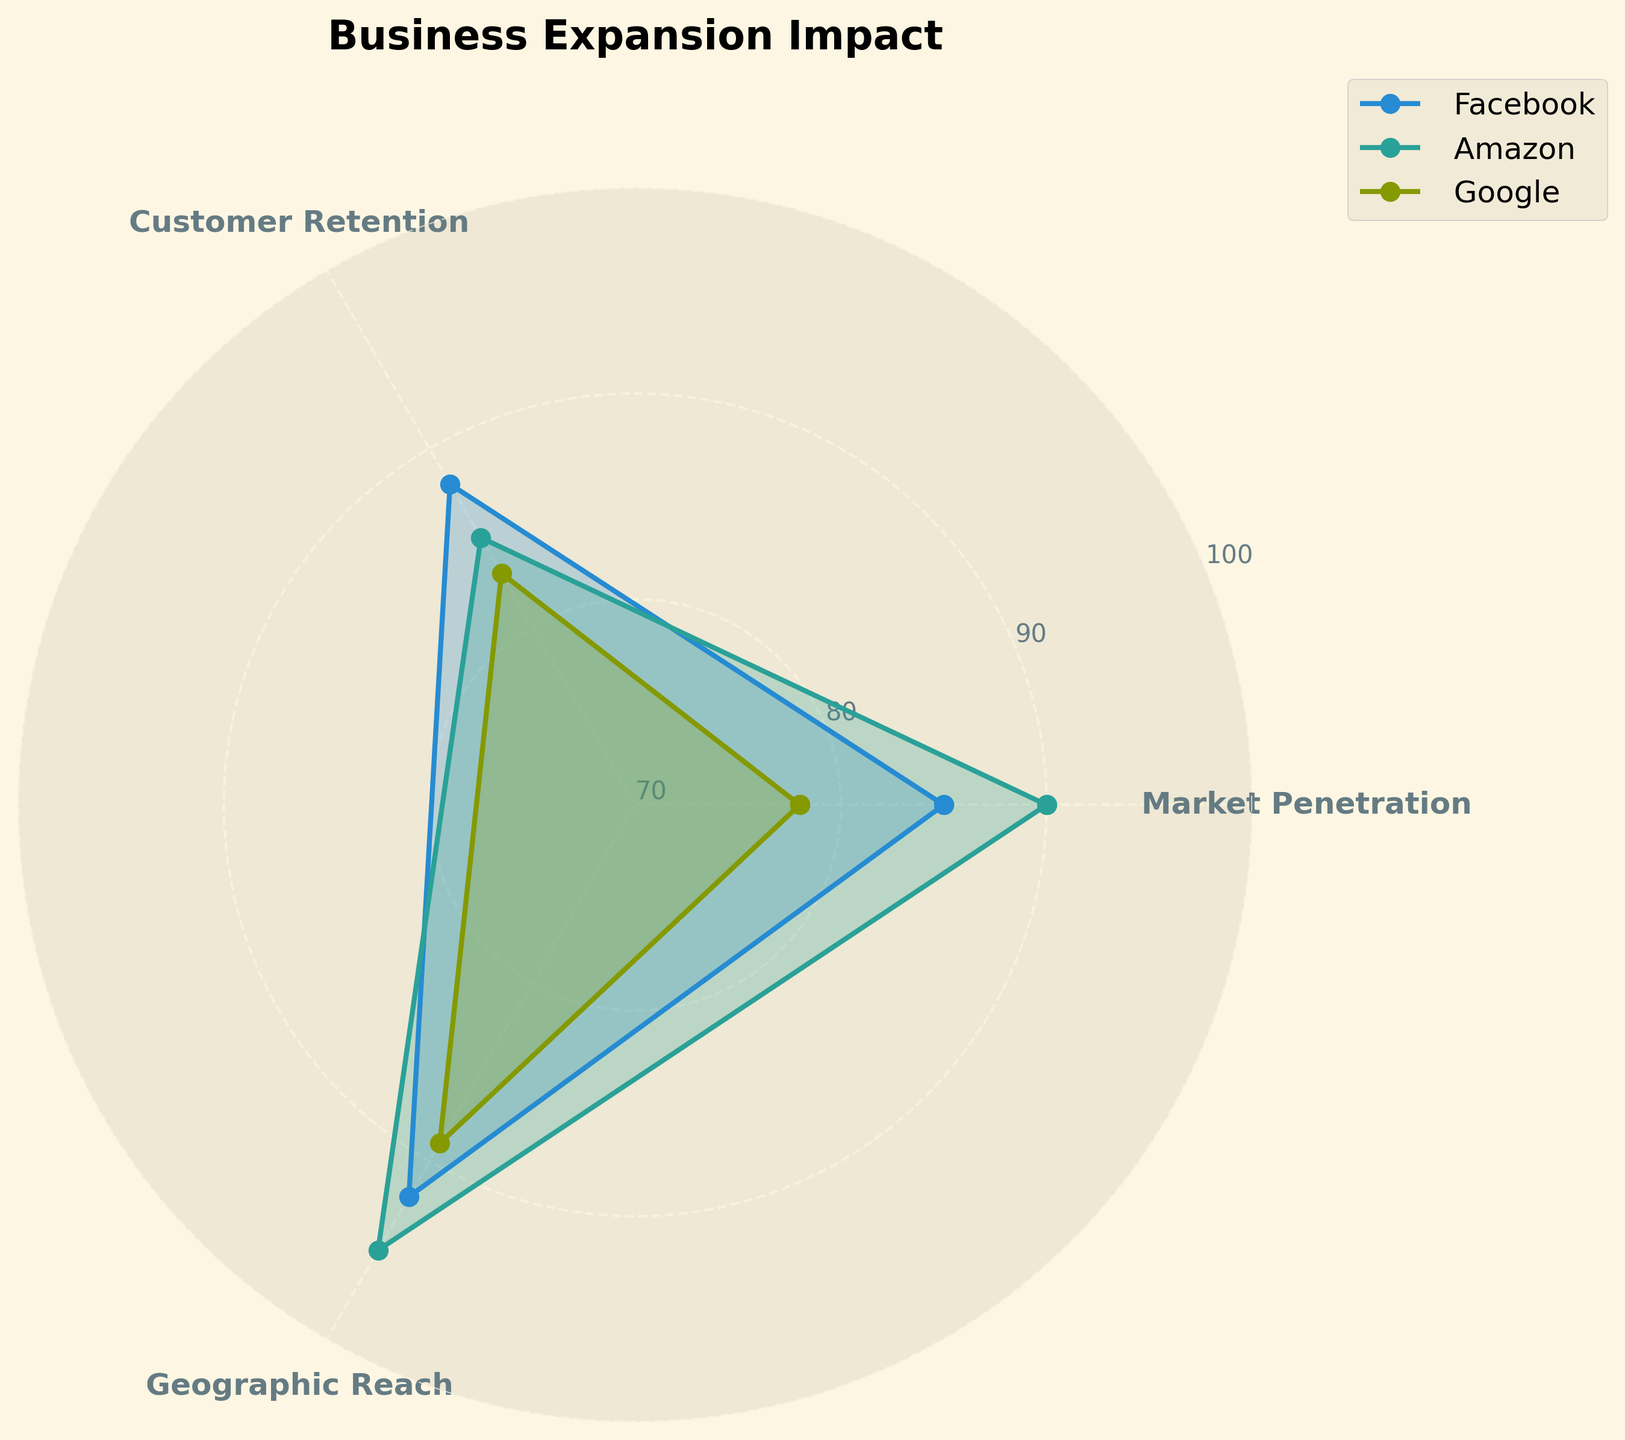What is the title of the radar chart? The title of the radar chart is displayed at the top, which gives a quick idea of what the data represents. The title reads "Business Expansion Impact."
Answer: Business Expansion Impact Which company has the highest Customer Retention value? On the radar chart, the Customer Retention values are clearly marked for each company. Amazon has the highest Customer Retention value at 88.
Answer: Amazon Compare the Market Penetration values of Facebook and Google. Which one is higher and by how much? The Market Penetration values for Facebook and Google are 85 and 78, respectively. To find the difference, subtract 78 from 85, giving a difference of 7.
Answer: Facebook, by 7 What is the average value of Geographic Reach across all three companies? The Geographic Reach values are 92 for Facebook, 95 for Amazon, and 89 for Google. Summing these values gives 276, and dividing by 3 yields an average of 92.
Answer: 92 Which company has the smallest range of values across all categories? To determine the range, subtract the smallest value from the largest for each company: Facebook (92-85=7), Amazon (95-85=10), and Google (89-78=11). Facebook has the smallest range at 7.
Answer: Facebook List the categories where Amazon outperforms Google. Amazon's values are higher in all categories: Market Penetration (90 vs. 78), Customer Retention (88 vs. 83), and Geographic Reach (95 vs. 89).
Answer: All categories What is the difference in the total impact (sum of all categories) between Google and Facebook? The sum of all categories for Google is 78+83+89=250 and for Facebook is 85+88+92=265. The difference is 265-250=15.
Answer: 15 What aspect shows the least difference between all three companies? Look at the variances across categories for each company: Market Penetration (12), Customer Retention (5), and Geographic Reach (6). Customer Retention has the least difference of 5.
Answer: Customer Retention On which axis does Facebook have its lowest value? Each axis corresponds to a category; Facebook's lowest value is in Market Penetration, where it scores 85.
Answer: Market Penetration Is there any category where all three companies score above 80? Check each category: Market Penetration (all above 78, but Google at 78), Customer Retention (all above 80), Geographic Reach (all above 80). The only category where all scores are above 80 is Customer Retention.
Answer: Customer Retention 